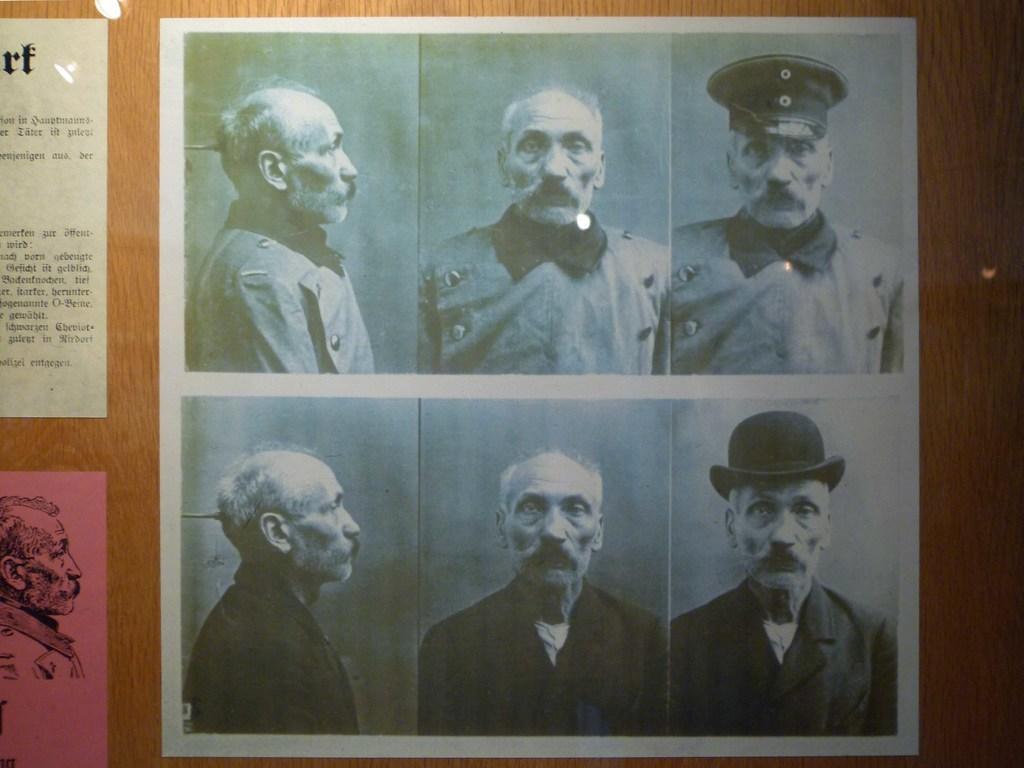In one or two sentences, can you explain what this image depicts? This image is taken indoors. In this image there is a wall with a few posts on it and there is a text and a few images on the poster. 